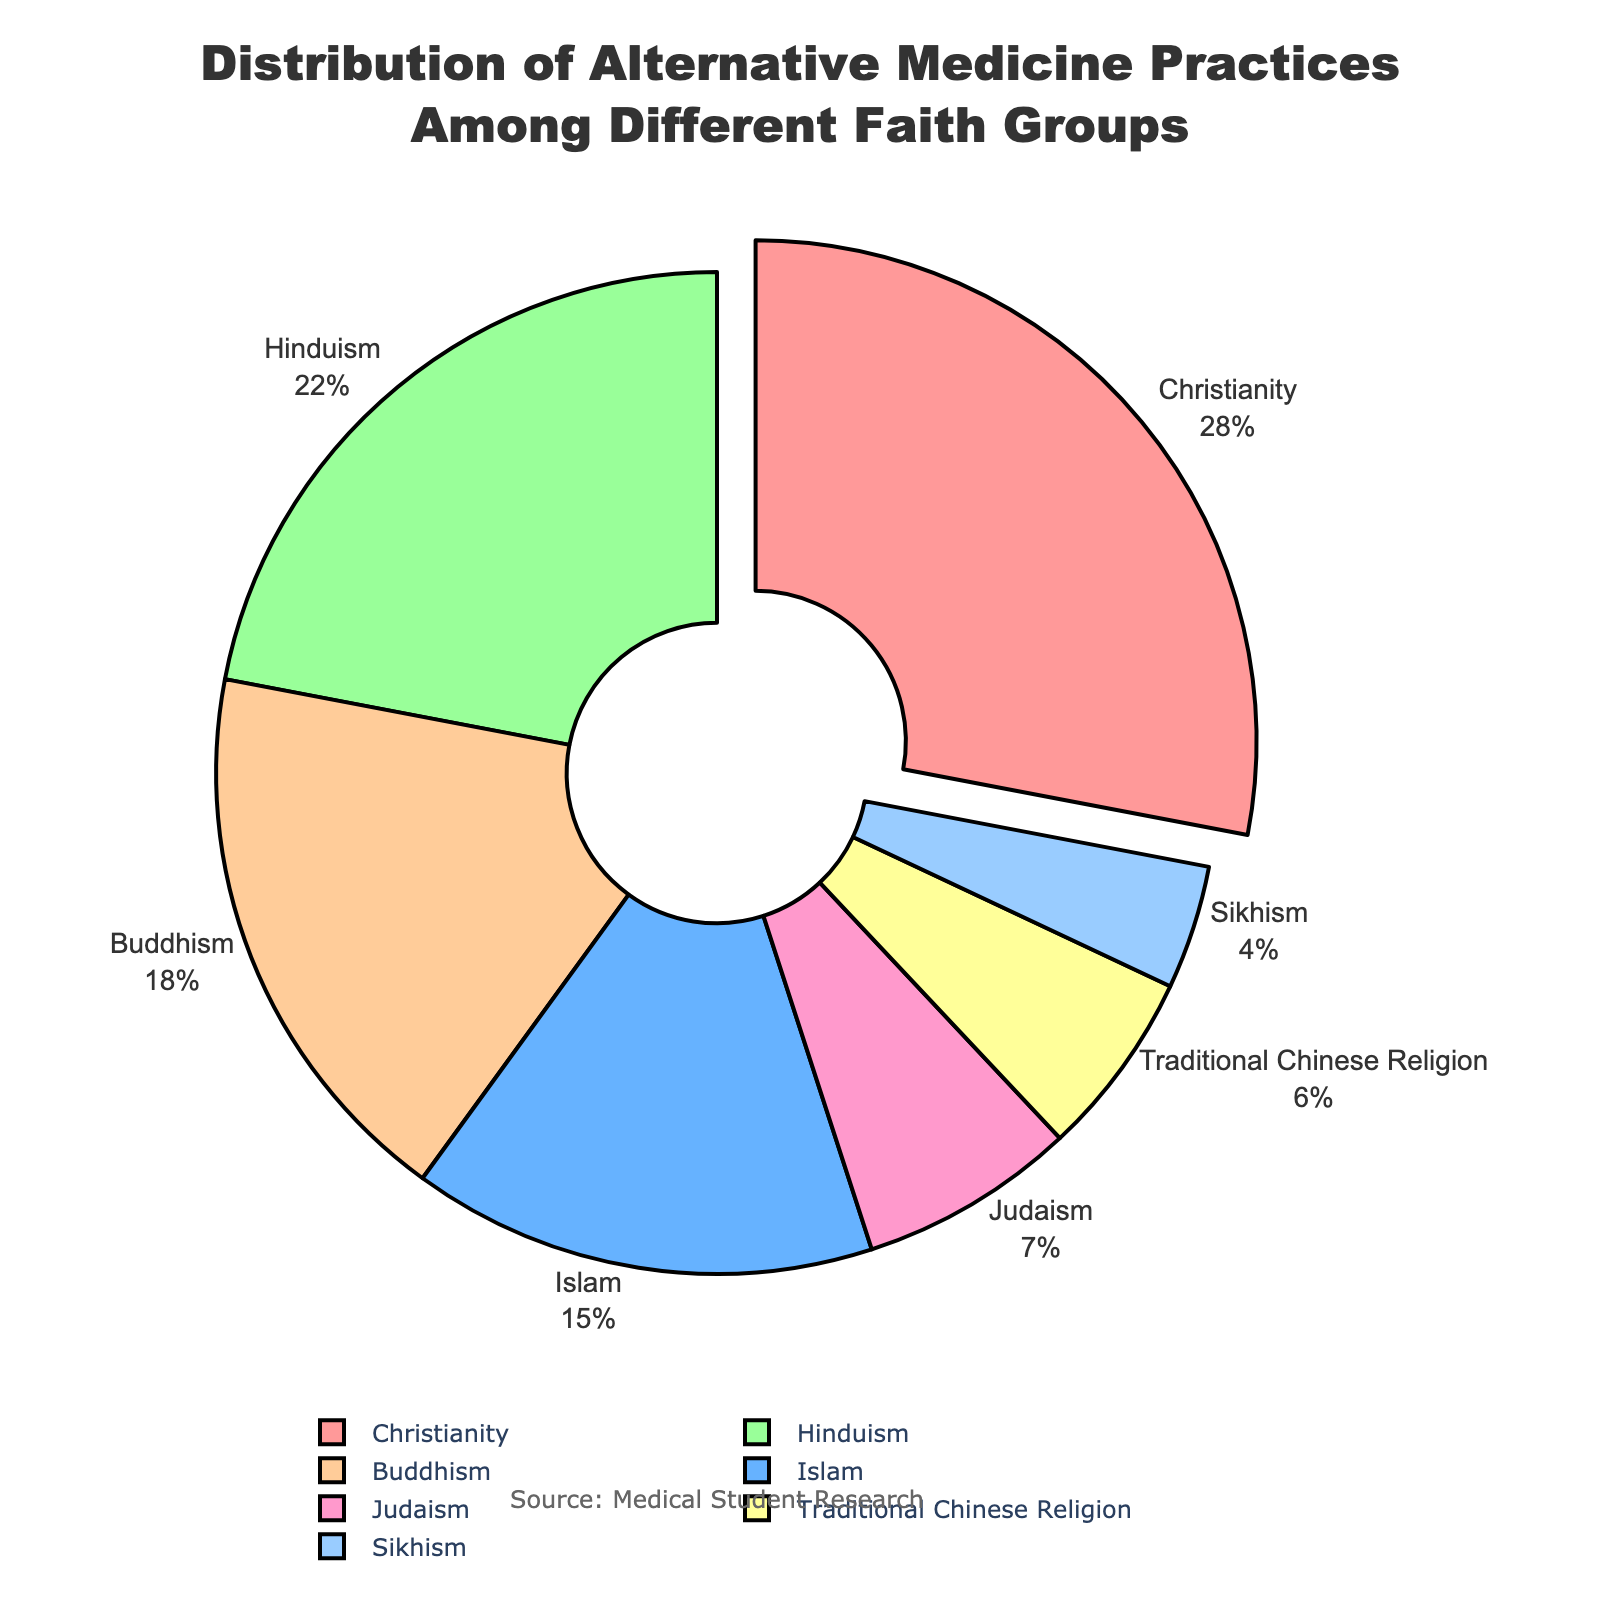what is the percentage of alternative medicine practices among Buddhists? To find the percentage of alternative medicine practices among Buddhists, look at the slice labeled "Buddhism" in the pie chart. The percentage value shown is directly from the data.
Answer: 18% Which faith group has the highest percentage of alternative medicine practices? Identify the slice of the pie chart that is visually the largest and has the highest percentage label. Christianity has the largest slice and also the percentage value of 28%, which is the highest.
Answer: Christianity How much more prevalent is alternative medicine among Christians compared to Jews? To determine the difference, locate the percentages for both Christianity and Judaism. Christianity's percentage is 28%, and Judaism's is 7%. Subtract the smaller percentage from the larger one: 28% - 7%.
Answer: 21% Considering Islam and Sikhism together, what's their combined percentage for alternative medicine practices? First, find the percentages for both Islam and Sikhism. Islam has 15% and Sikhism has 4%. Sum these percentages: 15% + 4%.
Answer: 19% Which faith groups have a percentage of alternative medicine practices lower than 10%? Look for slices in the chart that have labels with percentages under 10%. Judaism (7%) and Sikhism (4%) are the faith groups below 10%.
Answer: Judaism, Sikhism Rank the faith groups based on their percentage of alternative medicine practices from highest to lowest. Arrange the faith group labels by their numerical percentages in descending order. Christianity (28%), Hinduism (22%), Buddhism (18%), Islam (15%), Traditional Chinese Religion (6%), Judaism (7%), Sikhism (4%).
Answer: Christianity, Hinduism, Buddhism, Islam, Judaism, Traditional Chinese Religion, Sikhism What is the difference in percentage of alternative medicine practices between Hinduism and Buddhism? Locate the percentages for both Hinduism and Buddhism. For Hinduism, it is 22% and for Buddhism, it is 18%. Subtract the smaller percentage from the larger one: 22% - 18%.
Answer: 4% What color is the slice representing Traditional Chinese Religion? Identify the color of the slice labeled "Traditional Chinese Religion". The specific color mapping is observed from the pie chart. The slice for Traditional Chinese Religion is yellow in color.
Answer: yellow 